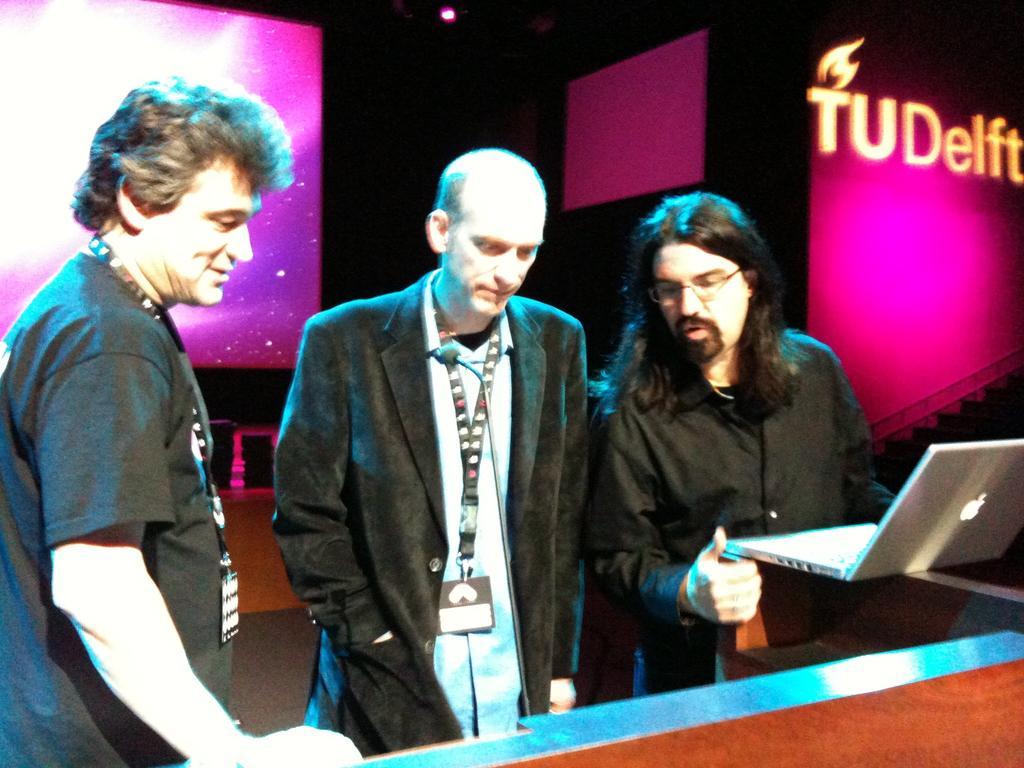Can you describe this image briefly? In this picture there are three persons standing and there is a person standing and holding the laptop. At the back there is a text on the wall. At the top there is a light. 